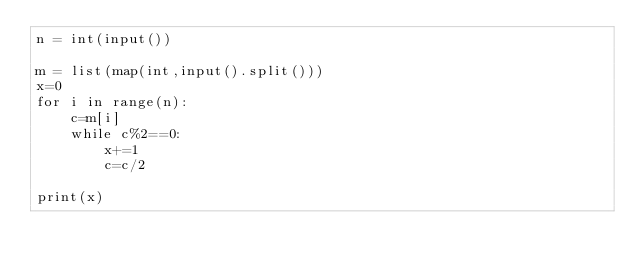Convert code to text. <code><loc_0><loc_0><loc_500><loc_500><_Python_>n = int(input())

m = list(map(int,input().split()))
x=0
for i in range(n):
    c=m[i]
    while c%2==0:
        x+=1
        c=c/2

print(x)</code> 